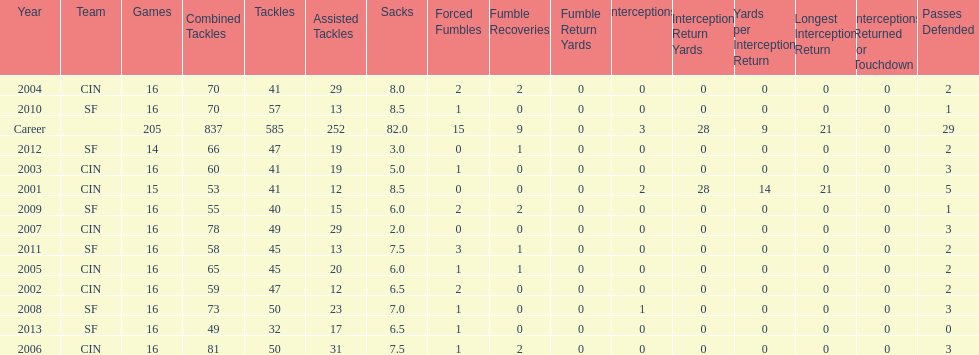What was the number of combined tackles in 2010? 70. 